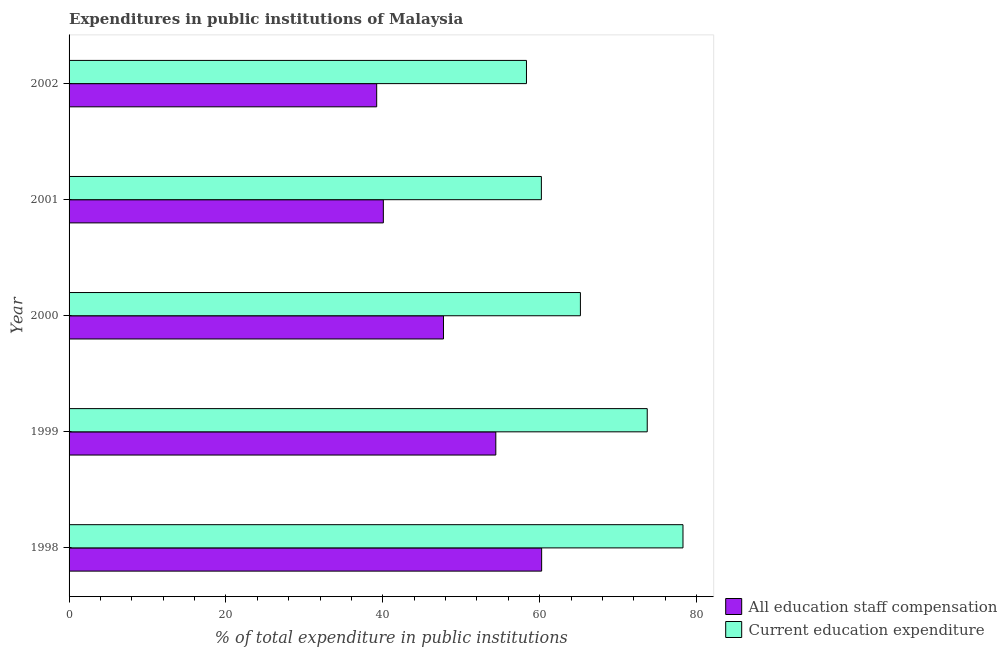Are the number of bars on each tick of the Y-axis equal?
Your response must be concise. Yes. What is the expenditure in education in 2002?
Keep it short and to the point. 58.31. Across all years, what is the maximum expenditure in staff compensation?
Ensure brevity in your answer.  60.25. Across all years, what is the minimum expenditure in staff compensation?
Make the answer very short. 39.22. In which year was the expenditure in staff compensation minimum?
Offer a terse response. 2002. What is the total expenditure in education in the graph?
Provide a succinct answer. 335.68. What is the difference between the expenditure in education in 2001 and that in 2002?
Give a very brief answer. 1.9. What is the difference between the expenditure in staff compensation in 1999 and the expenditure in education in 2002?
Your answer should be very brief. -3.91. What is the average expenditure in education per year?
Ensure brevity in your answer.  67.14. In the year 2002, what is the difference between the expenditure in staff compensation and expenditure in education?
Provide a short and direct response. -19.1. In how many years, is the expenditure in staff compensation greater than 8 %?
Your answer should be compact. 5. What is the ratio of the expenditure in staff compensation in 2000 to that in 2002?
Keep it short and to the point. 1.22. Is the difference between the expenditure in staff compensation in 1998 and 2002 greater than the difference between the expenditure in education in 1998 and 2002?
Your answer should be compact. Yes. What is the difference between the highest and the second highest expenditure in education?
Provide a short and direct response. 4.56. What is the difference between the highest and the lowest expenditure in staff compensation?
Make the answer very short. 21.03. In how many years, is the expenditure in staff compensation greater than the average expenditure in staff compensation taken over all years?
Your response must be concise. 2. What does the 1st bar from the top in 1998 represents?
Ensure brevity in your answer.  Current education expenditure. What does the 1st bar from the bottom in 2001 represents?
Ensure brevity in your answer.  All education staff compensation. Are all the bars in the graph horizontal?
Your answer should be compact. Yes. How many years are there in the graph?
Give a very brief answer. 5. What is the difference between two consecutive major ticks on the X-axis?
Your response must be concise. 20. Are the values on the major ticks of X-axis written in scientific E-notation?
Offer a terse response. No. Does the graph contain grids?
Give a very brief answer. No. Where does the legend appear in the graph?
Give a very brief answer. Bottom right. How many legend labels are there?
Provide a succinct answer. 2. What is the title of the graph?
Offer a very short reply. Expenditures in public institutions of Malaysia. Does "Highest 20% of population" appear as one of the legend labels in the graph?
Your response must be concise. No. What is the label or title of the X-axis?
Provide a succinct answer. % of total expenditure in public institutions. What is the label or title of the Y-axis?
Your answer should be very brief. Year. What is the % of total expenditure in public institutions of All education staff compensation in 1998?
Offer a very short reply. 60.25. What is the % of total expenditure in public institutions in Current education expenditure in 1998?
Your answer should be very brief. 78.27. What is the % of total expenditure in public institutions in All education staff compensation in 1999?
Give a very brief answer. 54.4. What is the % of total expenditure in public institutions in Current education expenditure in 1999?
Make the answer very short. 73.71. What is the % of total expenditure in public institutions of All education staff compensation in 2000?
Ensure brevity in your answer.  47.73. What is the % of total expenditure in public institutions of Current education expenditure in 2000?
Give a very brief answer. 65.19. What is the % of total expenditure in public institutions of All education staff compensation in 2001?
Your response must be concise. 40.07. What is the % of total expenditure in public institutions of Current education expenditure in 2001?
Your answer should be compact. 60.21. What is the % of total expenditure in public institutions in All education staff compensation in 2002?
Ensure brevity in your answer.  39.22. What is the % of total expenditure in public institutions in Current education expenditure in 2002?
Your response must be concise. 58.31. Across all years, what is the maximum % of total expenditure in public institutions of All education staff compensation?
Provide a short and direct response. 60.25. Across all years, what is the maximum % of total expenditure in public institutions of Current education expenditure?
Provide a succinct answer. 78.27. Across all years, what is the minimum % of total expenditure in public institutions in All education staff compensation?
Your answer should be very brief. 39.22. Across all years, what is the minimum % of total expenditure in public institutions in Current education expenditure?
Your answer should be compact. 58.31. What is the total % of total expenditure in public institutions of All education staff compensation in the graph?
Ensure brevity in your answer.  241.66. What is the total % of total expenditure in public institutions of Current education expenditure in the graph?
Ensure brevity in your answer.  335.68. What is the difference between the % of total expenditure in public institutions in All education staff compensation in 1998 and that in 1999?
Offer a terse response. 5.84. What is the difference between the % of total expenditure in public institutions in Current education expenditure in 1998 and that in 1999?
Provide a succinct answer. 4.56. What is the difference between the % of total expenditure in public institutions in All education staff compensation in 1998 and that in 2000?
Keep it short and to the point. 12.51. What is the difference between the % of total expenditure in public institutions of Current education expenditure in 1998 and that in 2000?
Provide a succinct answer. 13.08. What is the difference between the % of total expenditure in public institutions of All education staff compensation in 1998 and that in 2001?
Your response must be concise. 20.18. What is the difference between the % of total expenditure in public institutions of Current education expenditure in 1998 and that in 2001?
Provide a succinct answer. 18.05. What is the difference between the % of total expenditure in public institutions of All education staff compensation in 1998 and that in 2002?
Provide a succinct answer. 21.03. What is the difference between the % of total expenditure in public institutions in Current education expenditure in 1998 and that in 2002?
Your answer should be very brief. 19.95. What is the difference between the % of total expenditure in public institutions in All education staff compensation in 1999 and that in 2000?
Give a very brief answer. 6.67. What is the difference between the % of total expenditure in public institutions in Current education expenditure in 1999 and that in 2000?
Keep it short and to the point. 8.52. What is the difference between the % of total expenditure in public institutions of All education staff compensation in 1999 and that in 2001?
Ensure brevity in your answer.  14.34. What is the difference between the % of total expenditure in public institutions in Current education expenditure in 1999 and that in 2001?
Provide a succinct answer. 13.49. What is the difference between the % of total expenditure in public institutions in All education staff compensation in 1999 and that in 2002?
Keep it short and to the point. 15.19. What is the difference between the % of total expenditure in public institutions of Current education expenditure in 1999 and that in 2002?
Your answer should be very brief. 15.4. What is the difference between the % of total expenditure in public institutions in All education staff compensation in 2000 and that in 2001?
Offer a terse response. 7.67. What is the difference between the % of total expenditure in public institutions in Current education expenditure in 2000 and that in 2001?
Provide a short and direct response. 4.97. What is the difference between the % of total expenditure in public institutions in All education staff compensation in 2000 and that in 2002?
Your answer should be very brief. 8.52. What is the difference between the % of total expenditure in public institutions in Current education expenditure in 2000 and that in 2002?
Make the answer very short. 6.88. What is the difference between the % of total expenditure in public institutions of All education staff compensation in 2001 and that in 2002?
Your response must be concise. 0.85. What is the difference between the % of total expenditure in public institutions of Current education expenditure in 2001 and that in 2002?
Make the answer very short. 1.9. What is the difference between the % of total expenditure in public institutions of All education staff compensation in 1998 and the % of total expenditure in public institutions of Current education expenditure in 1999?
Ensure brevity in your answer.  -13.46. What is the difference between the % of total expenditure in public institutions of All education staff compensation in 1998 and the % of total expenditure in public institutions of Current education expenditure in 2000?
Your response must be concise. -4.94. What is the difference between the % of total expenditure in public institutions in All education staff compensation in 1998 and the % of total expenditure in public institutions in Current education expenditure in 2001?
Provide a succinct answer. 0.03. What is the difference between the % of total expenditure in public institutions in All education staff compensation in 1998 and the % of total expenditure in public institutions in Current education expenditure in 2002?
Provide a short and direct response. 1.93. What is the difference between the % of total expenditure in public institutions of All education staff compensation in 1999 and the % of total expenditure in public institutions of Current education expenditure in 2000?
Your response must be concise. -10.78. What is the difference between the % of total expenditure in public institutions of All education staff compensation in 1999 and the % of total expenditure in public institutions of Current education expenditure in 2001?
Your answer should be compact. -5.81. What is the difference between the % of total expenditure in public institutions of All education staff compensation in 1999 and the % of total expenditure in public institutions of Current education expenditure in 2002?
Make the answer very short. -3.91. What is the difference between the % of total expenditure in public institutions in All education staff compensation in 2000 and the % of total expenditure in public institutions in Current education expenditure in 2001?
Provide a succinct answer. -12.48. What is the difference between the % of total expenditure in public institutions of All education staff compensation in 2000 and the % of total expenditure in public institutions of Current education expenditure in 2002?
Ensure brevity in your answer.  -10.58. What is the difference between the % of total expenditure in public institutions in All education staff compensation in 2001 and the % of total expenditure in public institutions in Current education expenditure in 2002?
Offer a terse response. -18.25. What is the average % of total expenditure in public institutions in All education staff compensation per year?
Provide a succinct answer. 48.33. What is the average % of total expenditure in public institutions in Current education expenditure per year?
Give a very brief answer. 67.14. In the year 1998, what is the difference between the % of total expenditure in public institutions in All education staff compensation and % of total expenditure in public institutions in Current education expenditure?
Provide a short and direct response. -18.02. In the year 1999, what is the difference between the % of total expenditure in public institutions in All education staff compensation and % of total expenditure in public institutions in Current education expenditure?
Offer a terse response. -19.3. In the year 2000, what is the difference between the % of total expenditure in public institutions in All education staff compensation and % of total expenditure in public institutions in Current education expenditure?
Provide a succinct answer. -17.46. In the year 2001, what is the difference between the % of total expenditure in public institutions of All education staff compensation and % of total expenditure in public institutions of Current education expenditure?
Provide a short and direct response. -20.15. In the year 2002, what is the difference between the % of total expenditure in public institutions of All education staff compensation and % of total expenditure in public institutions of Current education expenditure?
Your response must be concise. -19.1. What is the ratio of the % of total expenditure in public institutions in All education staff compensation in 1998 to that in 1999?
Your answer should be very brief. 1.11. What is the ratio of the % of total expenditure in public institutions of Current education expenditure in 1998 to that in 1999?
Your answer should be compact. 1.06. What is the ratio of the % of total expenditure in public institutions in All education staff compensation in 1998 to that in 2000?
Offer a terse response. 1.26. What is the ratio of the % of total expenditure in public institutions in Current education expenditure in 1998 to that in 2000?
Your answer should be compact. 1.2. What is the ratio of the % of total expenditure in public institutions of All education staff compensation in 1998 to that in 2001?
Keep it short and to the point. 1.5. What is the ratio of the % of total expenditure in public institutions of Current education expenditure in 1998 to that in 2001?
Your answer should be very brief. 1.3. What is the ratio of the % of total expenditure in public institutions of All education staff compensation in 1998 to that in 2002?
Your response must be concise. 1.54. What is the ratio of the % of total expenditure in public institutions in Current education expenditure in 1998 to that in 2002?
Your response must be concise. 1.34. What is the ratio of the % of total expenditure in public institutions in All education staff compensation in 1999 to that in 2000?
Provide a succinct answer. 1.14. What is the ratio of the % of total expenditure in public institutions in Current education expenditure in 1999 to that in 2000?
Provide a short and direct response. 1.13. What is the ratio of the % of total expenditure in public institutions of All education staff compensation in 1999 to that in 2001?
Your answer should be very brief. 1.36. What is the ratio of the % of total expenditure in public institutions in Current education expenditure in 1999 to that in 2001?
Give a very brief answer. 1.22. What is the ratio of the % of total expenditure in public institutions of All education staff compensation in 1999 to that in 2002?
Provide a succinct answer. 1.39. What is the ratio of the % of total expenditure in public institutions in Current education expenditure in 1999 to that in 2002?
Make the answer very short. 1.26. What is the ratio of the % of total expenditure in public institutions in All education staff compensation in 2000 to that in 2001?
Offer a very short reply. 1.19. What is the ratio of the % of total expenditure in public institutions in Current education expenditure in 2000 to that in 2001?
Offer a very short reply. 1.08. What is the ratio of the % of total expenditure in public institutions of All education staff compensation in 2000 to that in 2002?
Your response must be concise. 1.22. What is the ratio of the % of total expenditure in public institutions in Current education expenditure in 2000 to that in 2002?
Ensure brevity in your answer.  1.12. What is the ratio of the % of total expenditure in public institutions of All education staff compensation in 2001 to that in 2002?
Your answer should be very brief. 1.02. What is the ratio of the % of total expenditure in public institutions of Current education expenditure in 2001 to that in 2002?
Your answer should be compact. 1.03. What is the difference between the highest and the second highest % of total expenditure in public institutions in All education staff compensation?
Your answer should be very brief. 5.84. What is the difference between the highest and the second highest % of total expenditure in public institutions in Current education expenditure?
Ensure brevity in your answer.  4.56. What is the difference between the highest and the lowest % of total expenditure in public institutions in All education staff compensation?
Keep it short and to the point. 21.03. What is the difference between the highest and the lowest % of total expenditure in public institutions in Current education expenditure?
Your response must be concise. 19.95. 